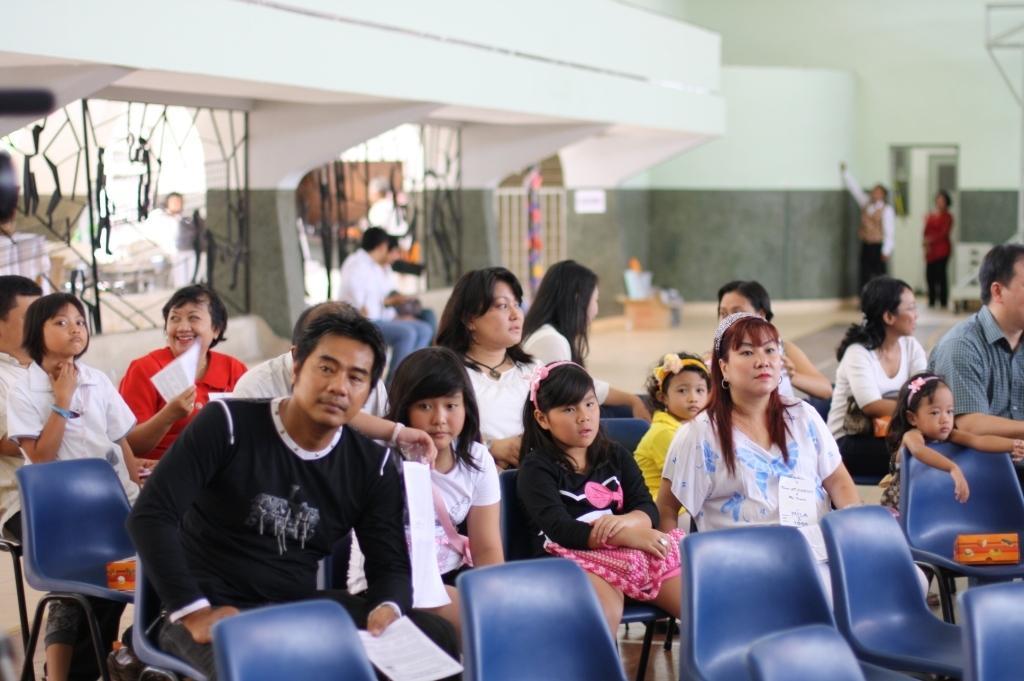In one or two sentences, can you explain what this image depicts? This image is clicked inside. There are so many chairs in this image. People are sitting on chairs. There there are two persons on the right side. Behind them there is an opening. 